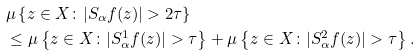Convert formula to latex. <formula><loc_0><loc_0><loc_500><loc_500>& \mu \left \{ z \in X \colon | S _ { \alpha } f ( z ) | > 2 \tau \right \} \\ & \leq \mu \left \{ z \in X \colon | S _ { \alpha } ^ { 1 } f ( z ) | > \tau \right \} + \mu \left \{ z \in X \colon | S _ { \alpha } ^ { 2 } f ( z ) | > \tau \right \} .</formula> 